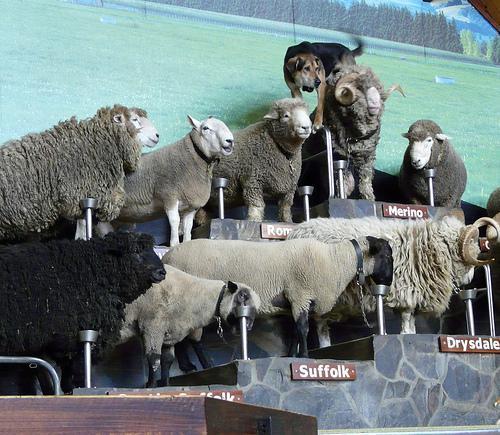How many dogs are in photo?
Give a very brief answer. 1. 